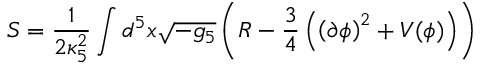<formula> <loc_0><loc_0><loc_500><loc_500>S = \frac { 1 } { 2 \kappa _ { 5 } ^ { 2 } } \int d ^ { 5 } x \sqrt { - g _ { 5 } } \left ( R - \frac { 3 } { 4 } \left ( \left ( \partial \phi \right ) ^ { 2 } + V ( \phi ) \right ) \right )</formula> 